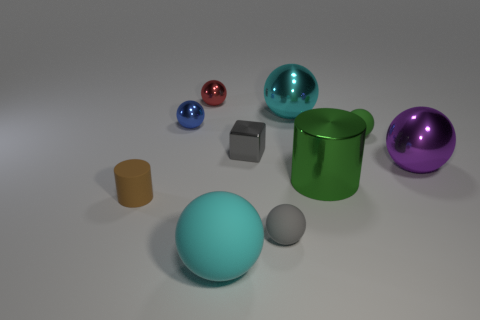If this were a scale model of a solar system, which object might represent the sun due to its size and placement? If we interpret this image as a scale model of a solar system, the large teal sphere in the center would likely represent the sun. Its central placement and larger size compared to the surrounding spheres make it a fitting central body, similar to how the sun is the largest object in our solar system and situated at the center. 